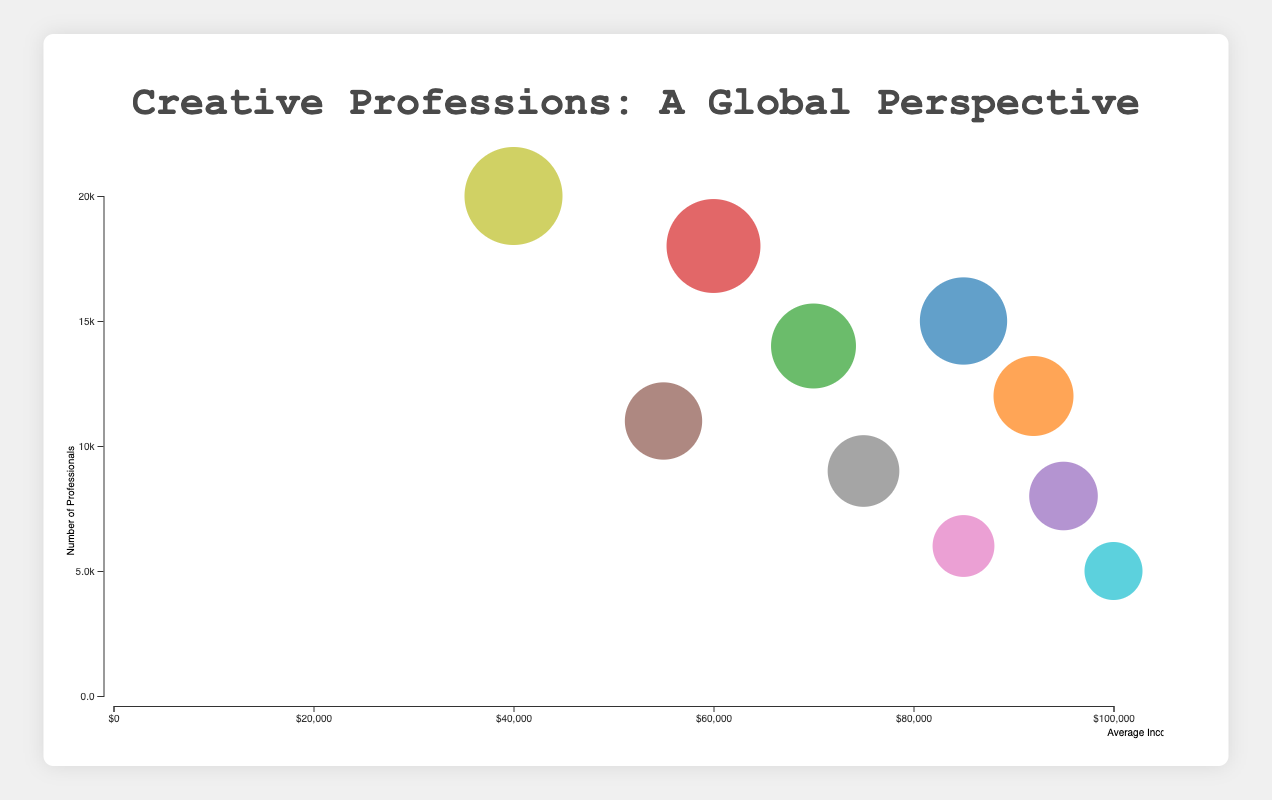What's the location with the highest average income for creative professions? By looking at the x-axis, we can identify which bubble is furthest to the right and see that Sydney, Australia has the highest average income.
Answer: Sydney, Australia Which location has the most creative professionals? By examining the y-axis and identifying the highest bubble, we can see that Mumbai, India has the most creative professionals.
Answer: Mumbai, India What is the profession associated with the lowest average income? By finding the bubble closest to the origin on the x-axis, we can see that Bollywood Scriptwriters in Mumbai, India have the lowest average income.
Answer: Bollywood Scriptwriters Are there more Fashion Designers in Paris or Graphic Designers in Berlin? By comparing the bubbles for Paris and Berlin on the y-axis, we observe that 8,000 is less than 11,000, indicating there are more Graphic Designers in Berlin.
Answer: Graphic Designers in Berlin How many bubbles represent locations in the USA? The bubbles for New York and Los Angeles represent locations in the USA, so there are two bubbles.
Answer: 2 Which profession in the figure has both high average income and a moderate number of professionals? Film Directors in Sydney has the highest average income (furthest right on the x-axis) and bubble size (sizeable but not the largest).
Answer: Film Directors Is the average income of Manga Artists higher or lower than K-Pop Songwriters? By locating the bubbles and comparing their positions on the x-axis, we see that Manga Artists in Tokyo have an average income of $60,000, which is lower than the $75,000 of K-Pop Songwriters in Seoul.
Answer: Lower Which location has a similar average income for creative professionals as Stockholm, Sweden? By identifying nearby bubbles on the x-axis to the bubble for Stockholm, we see that New York, USA has an average income similar to Stockholm, Sweden.
Answer: New York, USA What is the average income range for the creative professions in the chart? The chart's x-axis ranges from $40,000 to $100,000 for average income, based on the positions of the relevant bubbles on the axis.
Answer: $40,000 to $100,000 Is there any profession with an average income around $90,000? By observing the bubbles in proximity to the $90,000 mark on the x-axis, we find Screenwriters in Los Angeles close to that value.
Answer: Screenwriters in Los Angeles 